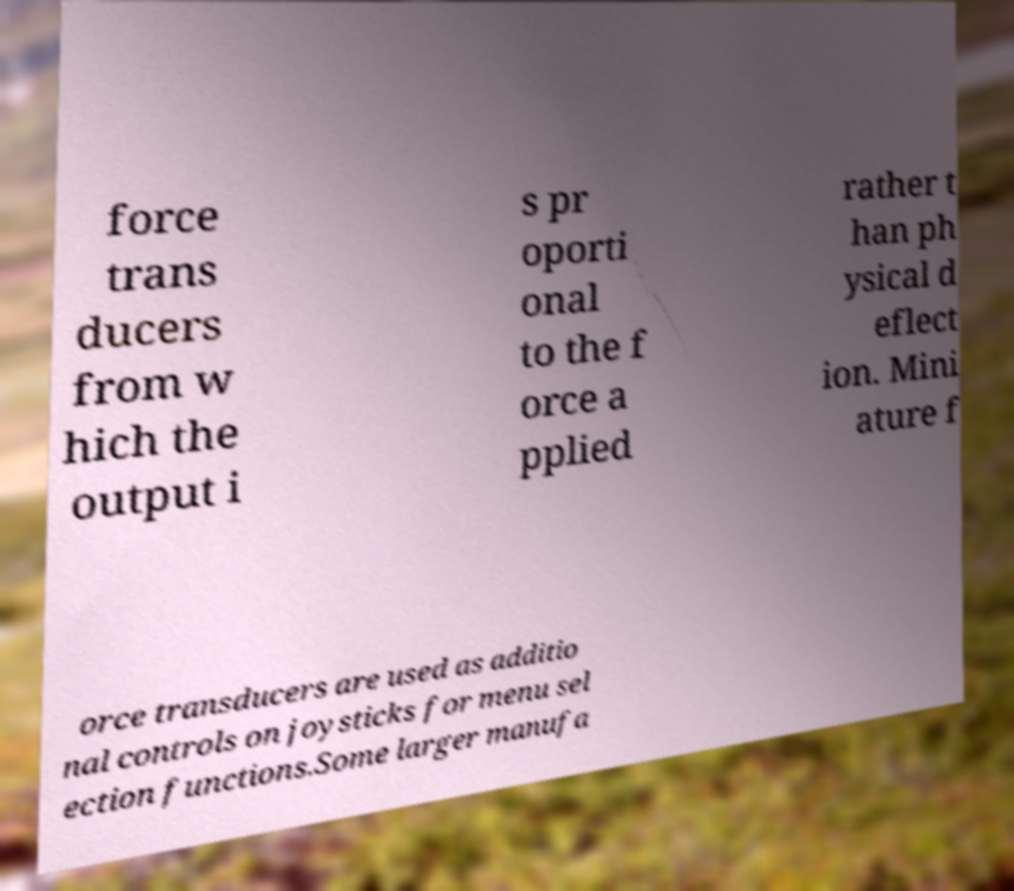Could you extract and type out the text from this image? force trans ducers from w hich the output i s pr oporti onal to the f orce a pplied rather t han ph ysical d eflect ion. Mini ature f orce transducers are used as additio nal controls on joysticks for menu sel ection functions.Some larger manufa 